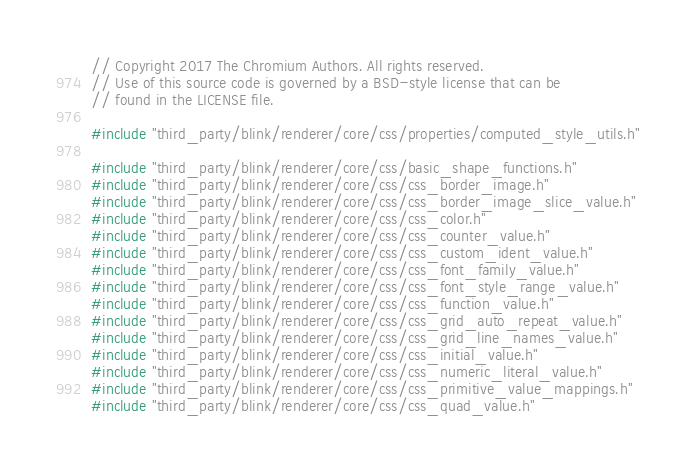<code> <loc_0><loc_0><loc_500><loc_500><_C++_>// Copyright 2017 The Chromium Authors. All rights reserved.
// Use of this source code is governed by a BSD-style license that can be
// found in the LICENSE file.

#include "third_party/blink/renderer/core/css/properties/computed_style_utils.h"

#include "third_party/blink/renderer/core/css/basic_shape_functions.h"
#include "third_party/blink/renderer/core/css/css_border_image.h"
#include "third_party/blink/renderer/core/css/css_border_image_slice_value.h"
#include "third_party/blink/renderer/core/css/css_color.h"
#include "third_party/blink/renderer/core/css/css_counter_value.h"
#include "third_party/blink/renderer/core/css/css_custom_ident_value.h"
#include "third_party/blink/renderer/core/css/css_font_family_value.h"
#include "third_party/blink/renderer/core/css/css_font_style_range_value.h"
#include "third_party/blink/renderer/core/css/css_function_value.h"
#include "third_party/blink/renderer/core/css/css_grid_auto_repeat_value.h"
#include "third_party/blink/renderer/core/css/css_grid_line_names_value.h"
#include "third_party/blink/renderer/core/css/css_initial_value.h"
#include "third_party/blink/renderer/core/css/css_numeric_literal_value.h"
#include "third_party/blink/renderer/core/css/css_primitive_value_mappings.h"
#include "third_party/blink/renderer/core/css/css_quad_value.h"</code> 